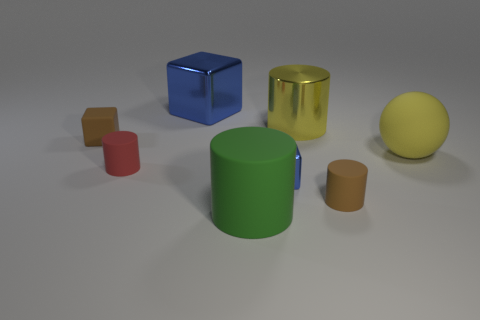Subtract all large yellow metal cylinders. How many cylinders are left? 3 Subtract all blue blocks. How many blocks are left? 1 Add 1 large yellow shiny cylinders. How many objects exist? 9 Subtract all cubes. How many objects are left? 5 Subtract 3 cylinders. How many cylinders are left? 1 Subtract all gray cubes. Subtract all purple cylinders. How many cubes are left? 3 Subtract all green cylinders. How many blue cubes are left? 2 Subtract all tiny blue objects. Subtract all large things. How many objects are left? 3 Add 3 red cylinders. How many red cylinders are left? 4 Add 7 large metal balls. How many large metal balls exist? 7 